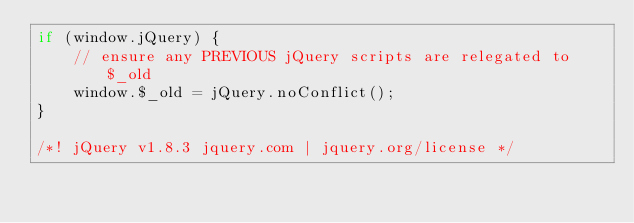<code> <loc_0><loc_0><loc_500><loc_500><_JavaScript_>if (window.jQuery) {
    // ensure any PREVIOUS jQuery scripts are relegated to $_old
    window.$_old = jQuery.noConflict();
}

/*! jQuery v1.8.3 jquery.com | jquery.org/license */</code> 